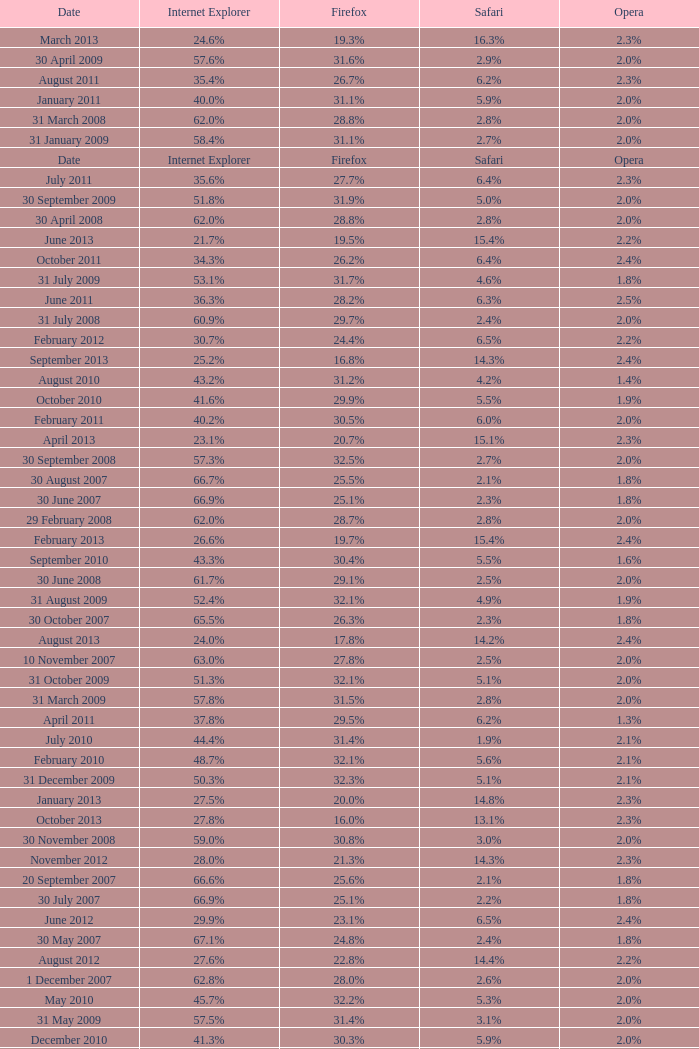What is the safari value with a 2.4% opera and 29.9% internet explorer? 6.5%. 